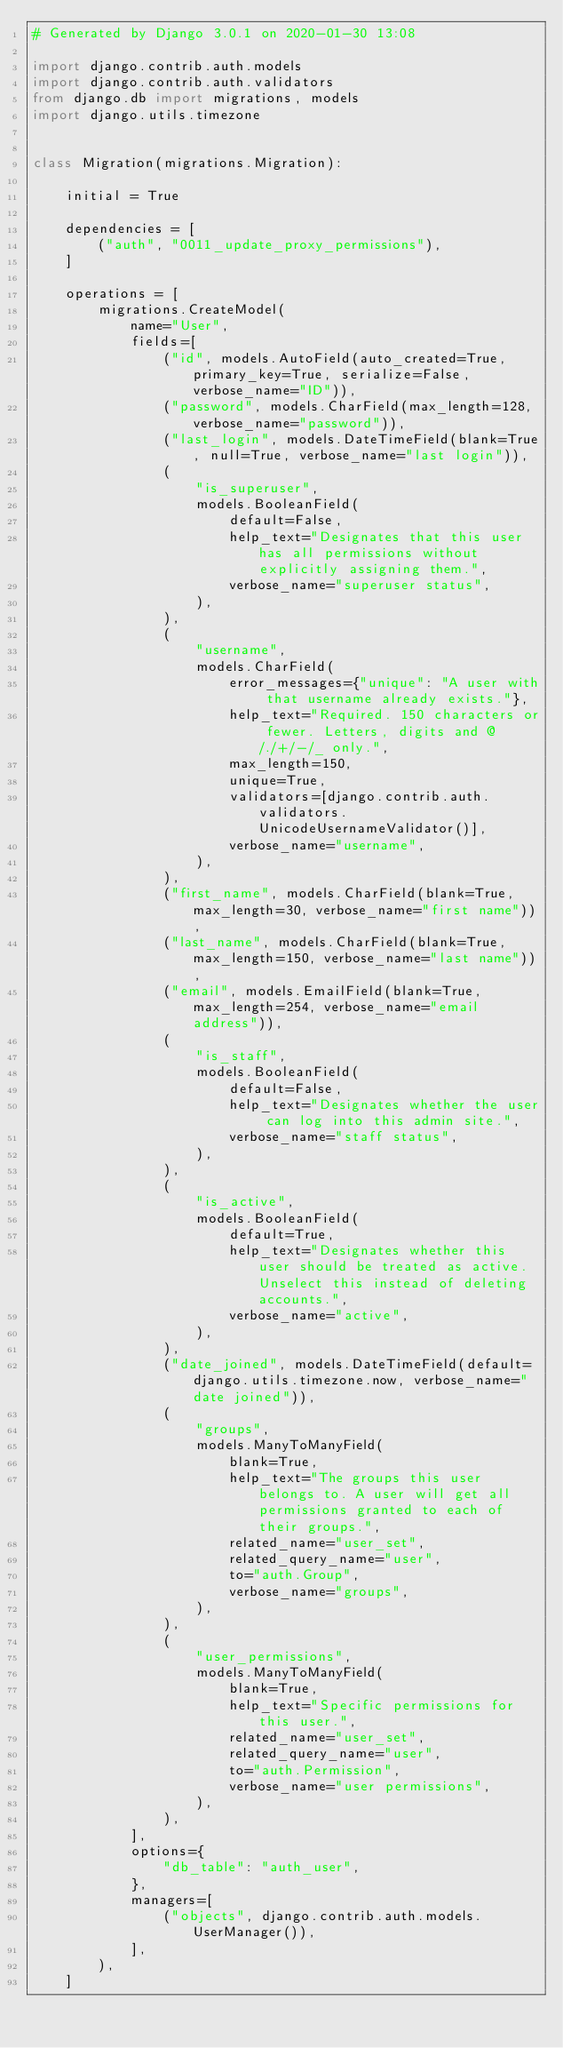<code> <loc_0><loc_0><loc_500><loc_500><_Python_># Generated by Django 3.0.1 on 2020-01-30 13:08

import django.contrib.auth.models
import django.contrib.auth.validators
from django.db import migrations, models
import django.utils.timezone


class Migration(migrations.Migration):

    initial = True

    dependencies = [
        ("auth", "0011_update_proxy_permissions"),
    ]

    operations = [
        migrations.CreateModel(
            name="User",
            fields=[
                ("id", models.AutoField(auto_created=True, primary_key=True, serialize=False, verbose_name="ID")),
                ("password", models.CharField(max_length=128, verbose_name="password")),
                ("last_login", models.DateTimeField(blank=True, null=True, verbose_name="last login")),
                (
                    "is_superuser",
                    models.BooleanField(
                        default=False,
                        help_text="Designates that this user has all permissions without explicitly assigning them.",
                        verbose_name="superuser status",
                    ),
                ),
                (
                    "username",
                    models.CharField(
                        error_messages={"unique": "A user with that username already exists."},
                        help_text="Required. 150 characters or fewer. Letters, digits and @/./+/-/_ only.",
                        max_length=150,
                        unique=True,
                        validators=[django.contrib.auth.validators.UnicodeUsernameValidator()],
                        verbose_name="username",
                    ),
                ),
                ("first_name", models.CharField(blank=True, max_length=30, verbose_name="first name")),
                ("last_name", models.CharField(blank=True, max_length=150, verbose_name="last name")),
                ("email", models.EmailField(blank=True, max_length=254, verbose_name="email address")),
                (
                    "is_staff",
                    models.BooleanField(
                        default=False,
                        help_text="Designates whether the user can log into this admin site.",
                        verbose_name="staff status",
                    ),
                ),
                (
                    "is_active",
                    models.BooleanField(
                        default=True,
                        help_text="Designates whether this user should be treated as active. Unselect this instead of deleting accounts.",
                        verbose_name="active",
                    ),
                ),
                ("date_joined", models.DateTimeField(default=django.utils.timezone.now, verbose_name="date joined")),
                (
                    "groups",
                    models.ManyToManyField(
                        blank=True,
                        help_text="The groups this user belongs to. A user will get all permissions granted to each of their groups.",
                        related_name="user_set",
                        related_query_name="user",
                        to="auth.Group",
                        verbose_name="groups",
                    ),
                ),
                (
                    "user_permissions",
                    models.ManyToManyField(
                        blank=True,
                        help_text="Specific permissions for this user.",
                        related_name="user_set",
                        related_query_name="user",
                        to="auth.Permission",
                        verbose_name="user permissions",
                    ),
                ),
            ],
            options={
                "db_table": "auth_user",
            },
            managers=[
                ("objects", django.contrib.auth.models.UserManager()),
            ],
        ),
    ]
</code> 